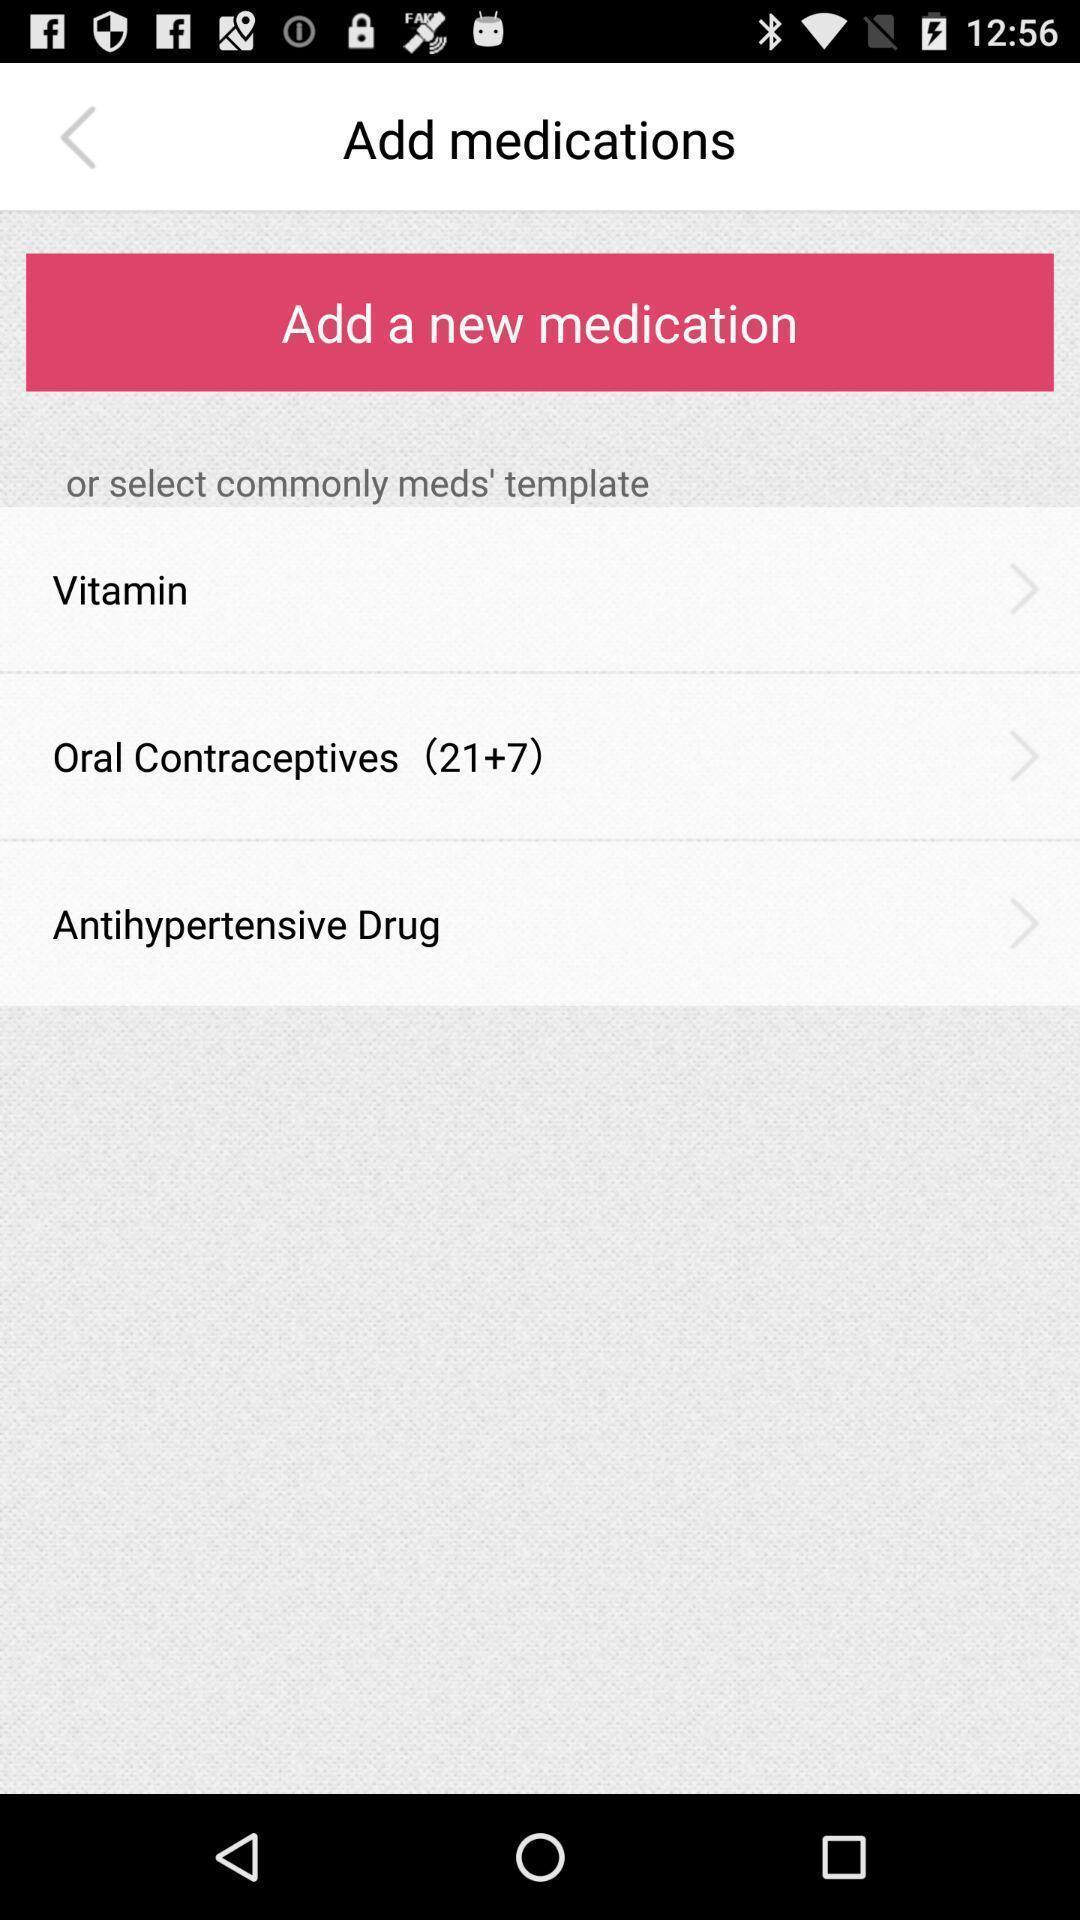Give me a summary of this screen capture. Screen asks to add a new medication. 